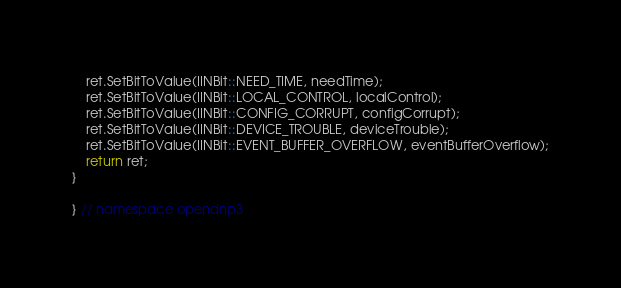Convert code to text. <code><loc_0><loc_0><loc_500><loc_500><_C++_>    ret.SetBitToValue(IINBit::NEED_TIME, needTime);
    ret.SetBitToValue(IINBit::LOCAL_CONTROL, localControl);
    ret.SetBitToValue(IINBit::CONFIG_CORRUPT, configCorrupt);
    ret.SetBitToValue(IINBit::DEVICE_TROUBLE, deviceTrouble);
    ret.SetBitToValue(IINBit::EVENT_BUFFER_OVERFLOW, eventBufferOverflow);
    return ret;
}

} // namespace opendnp3
</code> 